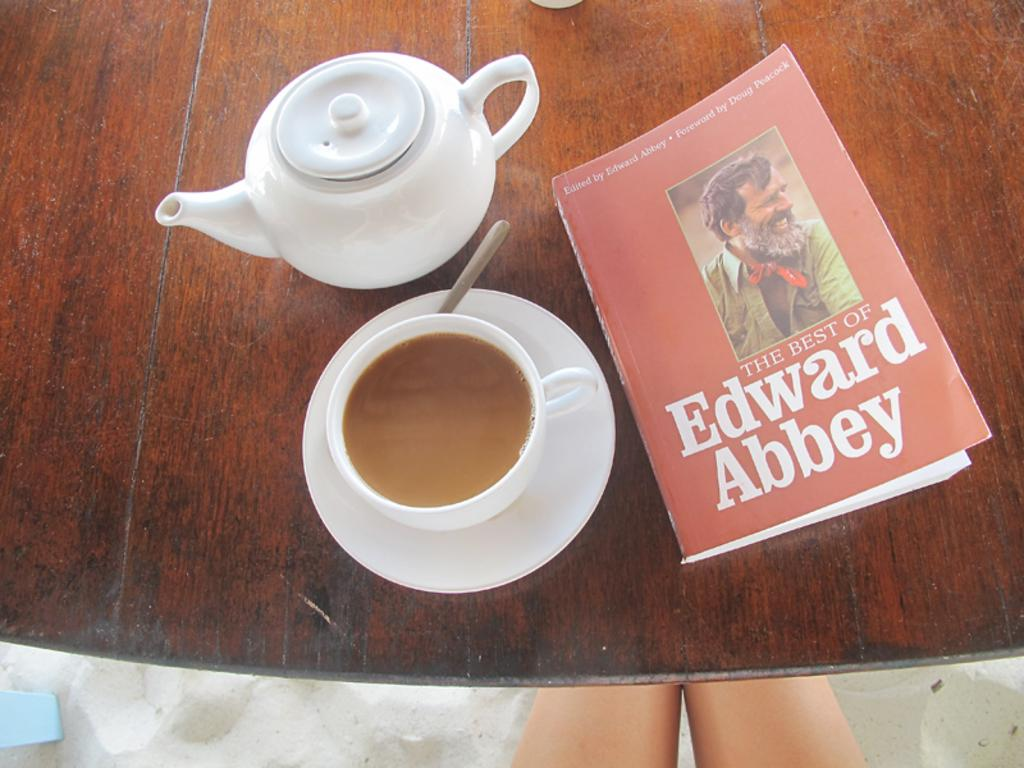<image>
Offer a succinct explanation of the picture presented. A cup of tea with milk along with a copy of  "The Best of Edward Abbey" on a rustic table. 